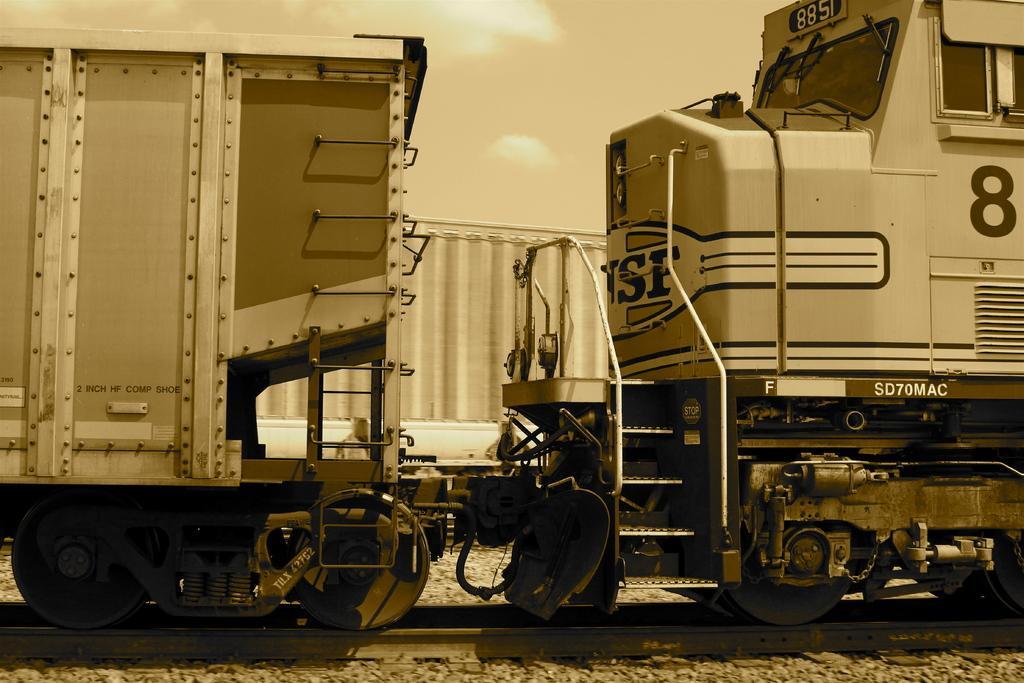Could you give a brief overview of what you see in this image? In this image there is the sky, there are clouds in the sky, there are trains truncated, there is a railway track. 